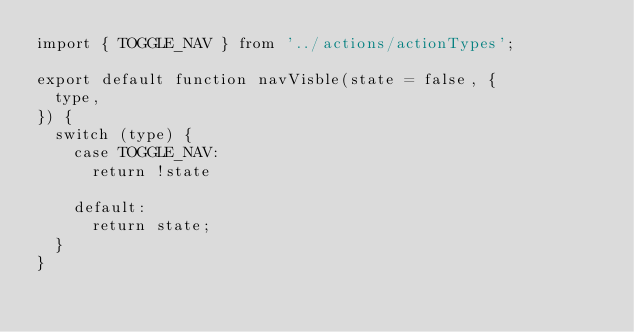<code> <loc_0><loc_0><loc_500><loc_500><_JavaScript_>import { TOGGLE_NAV } from '../actions/actionTypes';

export default function navVisble(state = false, {
  type,
}) {
  switch (type) {
    case TOGGLE_NAV:
      return !state

    default:
      return state;
  }
}
</code> 